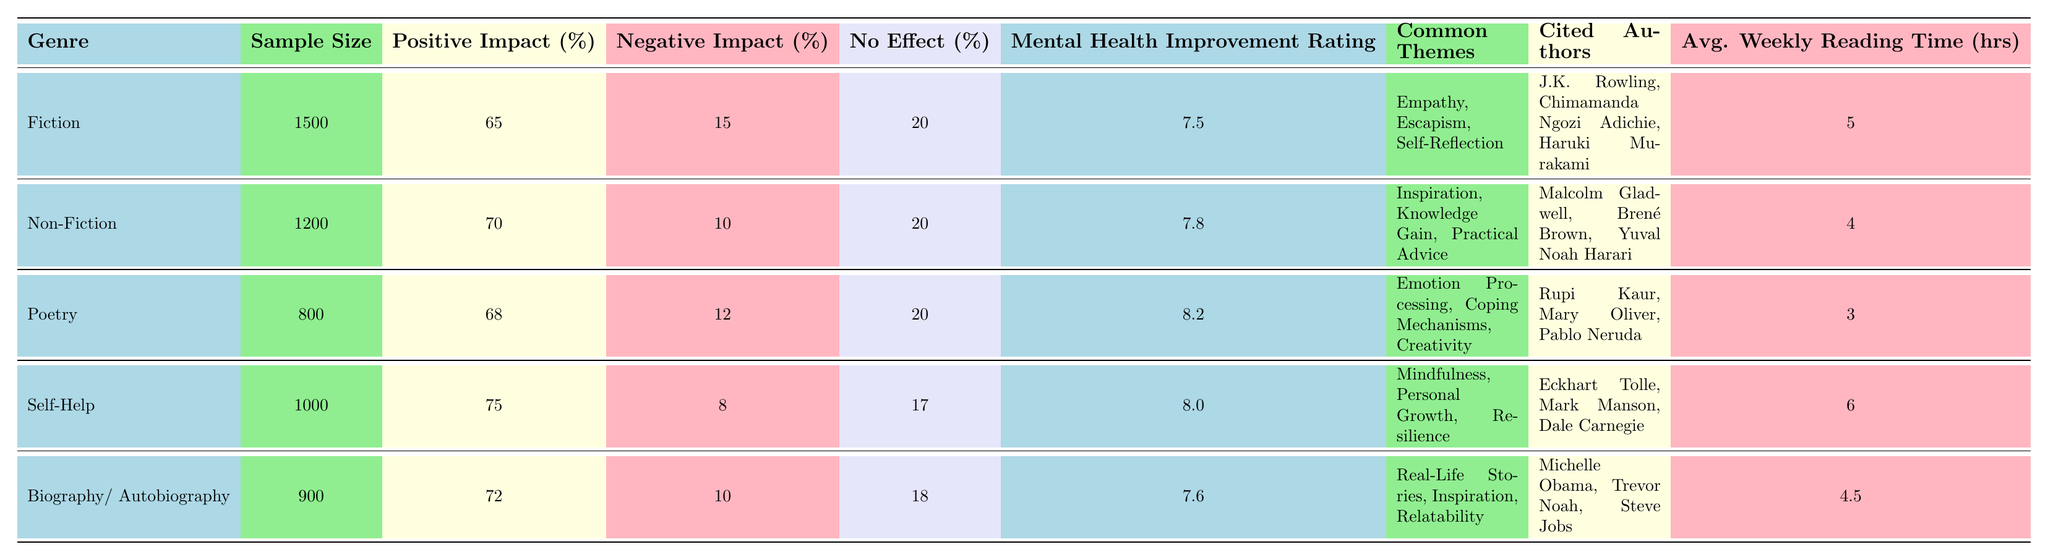What is the average weekly reading time for poetry? The average weekly reading time for poetry is provided directly in the table under the respective column, which shows a value of 3 hours per week.
Answer: 3 Which genre has the highest percentage of positive impact on mental health? By comparing the positive impact percentages in the table, the Self-Help genre shows the highest percentage at 75%.
Answer: Self-Help What is the mental health improvement rating for fiction? The mental health improvement rating for the Fiction genre is listed in the table as 7.5.
Answer: 7.5 Is the negative impact percentage for self-help lower than that for poetry? The negative impact percentage for Self-Help is 8%, while for Poetry it is 12%. Since 8% is less than 12%, the statement is true.
Answer: Yes What is the combined average weekly reading time for fiction and biography/autobiography? The average weekly reading time for Fiction is 5 hours and for Biography/Autobiography is 4.5 hours. Adding these gives (5 + 4.5) = 9.5 hours.
Answer: 9.5 Which genre cited authors who are primarily known for inspiration themes? The genres listed with common themes of inspiration include Non-Fiction and Biography/Autobiography, both showing authors known for providing inspiration (like Malcolm Gladwell and Michelle Obama).
Answer: Non-Fiction and Biography/Autobiography What percentage of respondents reported no effect from reading non-fiction? The table shows that 20% of respondents reported no effect from reading Non-Fiction.
Answer: 20% Calculate the difference in the mental health improvement rating between poetry and fiction. The mental health improvement rating for Poetry is 8.2 and for Fiction is 7.5. Subtracting these gives (8.2 - 7.5) = 0.7, indicating that Poetry has a higher rating by 0.7 points.
Answer: 0.7 What is the total sample size of respondents for all genres combined? Adding the sample sizes for all the genres (Fiction: 1500, Non-Fiction: 1200, Poetry: 800, Self-Help: 1000, Biography/Autobiography: 900) gives a total of (1500 + 1200 + 800 + 1000 + 900) = 4400.
Answer: 4400 Do more people report a negative impact from reading fiction compared to poetry? According to the table, 15% of fiction readers reported a negative impact, while 12% of poetry readers did. Since 15% is greater than 12%, the answer is yes.
Answer: Yes 